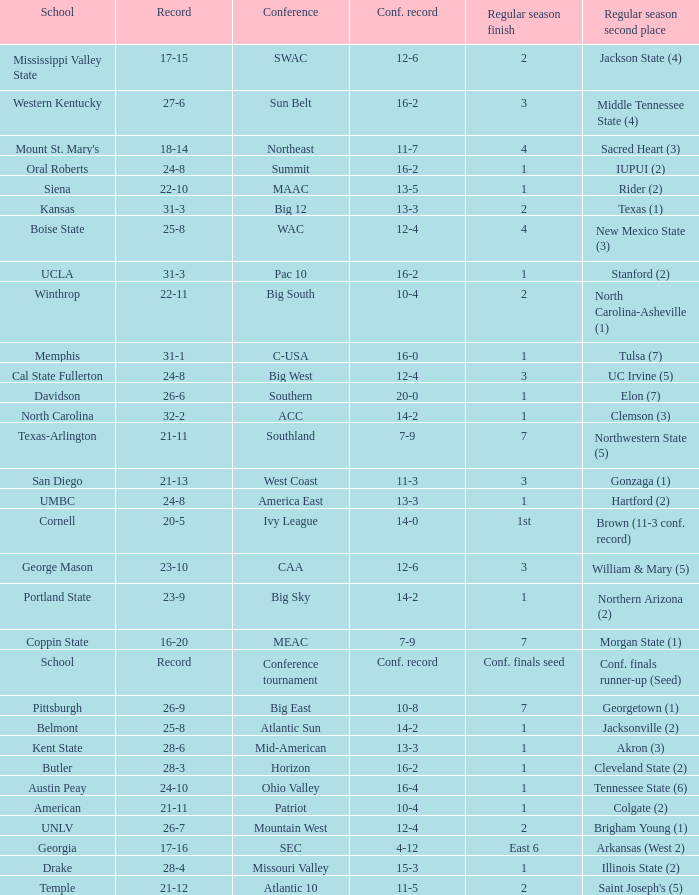For teams in the Sun Belt conference, what is the conference record? 16-2. 